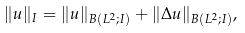<formula> <loc_0><loc_0><loc_500><loc_500>\| u \| _ { I } = \| u \| _ { B ( L ^ { 2 } ; I ) } + \| \Delta u \| _ { B ( L ^ { 2 } ; I ) } ,</formula> 